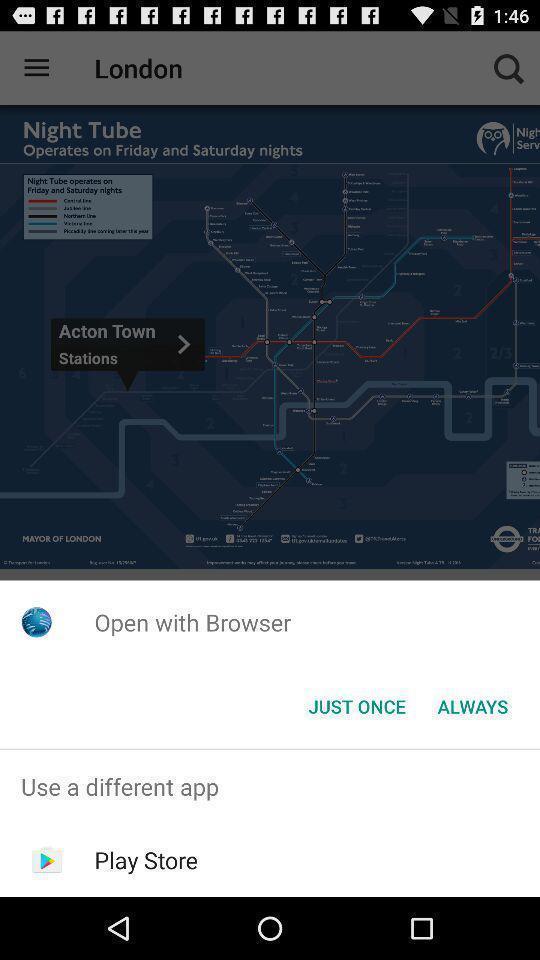Explain the elements present in this screenshot. Pop-up shows open with browser. 